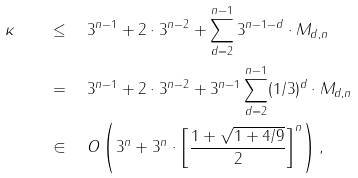Convert formula to latex. <formula><loc_0><loc_0><loc_500><loc_500>\kappa \quad & \leq \quad 3 ^ { n - 1 } + 2 \cdot 3 ^ { n - 2 } + \sum _ { d = 2 } ^ { n - 1 } 3 ^ { n - 1 - d } \cdot M _ { d , n } \\ & = \quad 3 ^ { n - 1 } + 2 \cdot 3 ^ { n - 2 } + 3 ^ { n - 1 } \sum _ { d = 2 } ^ { n - 1 } ( 1 / 3 ) ^ { d } \cdot M _ { d , n } \\ & \in \quad O \left ( 3 ^ { n } + 3 ^ { n } \cdot \left [ \frac { 1 + \sqrt { 1 + 4 / 9 } } { 2 } \right ] ^ { n } \right ) ,</formula> 